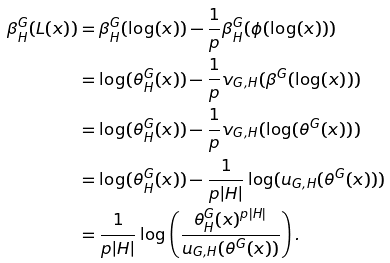Convert formula to latex. <formula><loc_0><loc_0><loc_500><loc_500>\beta ^ { G } _ { H } ( L ( x ) ) & = \beta ^ { G } _ { H } ( \log ( x ) ) - \frac { 1 } { p } \beta ^ { G } _ { H } ( \phi ( \log ( x ) ) ) \\ & = \log ( \theta ^ { G } _ { H } ( x ) ) - \frac { 1 } { p } v _ { G , H } ( \beta ^ { G } ( \log ( x ) ) ) \\ & = \log ( \theta ^ { G } _ { H } ( x ) ) - \frac { 1 } { p } v _ { G , H } ( \log ( \theta ^ { G } ( x ) ) ) \\ & = \log ( \theta ^ { G } _ { H } ( x ) ) - \frac { 1 } { p | H | } \log ( u _ { G , H } ( \theta ^ { G } ( x ) ) ) \\ & = \frac { 1 } { p | H | } \log \left ( \frac { \theta ^ { G } _ { H } ( x ) ^ { p | H | } } { u _ { G , H } ( \theta ^ { G } ( x ) ) } \right ) .</formula> 